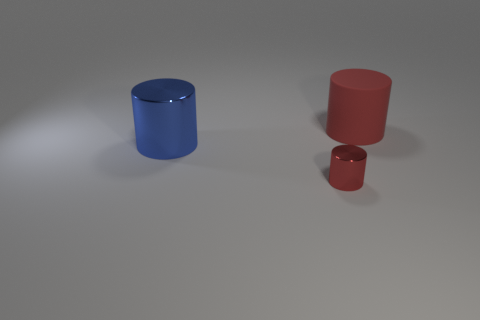How many tiny objects are red rubber objects or cyan metallic balls?
Provide a short and direct response. 0. There is a tiny red thing that is the same shape as the large blue metal thing; what material is it?
Offer a terse response. Metal. Is there any other thing that has the same material as the large red cylinder?
Your answer should be compact. No. What is the color of the small metal thing?
Provide a succinct answer. Red. Does the rubber cylinder have the same color as the small shiny object?
Make the answer very short. Yes. There is a big cylinder right of the blue cylinder; how many big red objects are on the left side of it?
Your answer should be compact. 0. There is a cylinder that is to the right of the blue object and in front of the matte cylinder; what is its size?
Provide a short and direct response. Small. What material is the large cylinder to the right of the tiny metal thing?
Your response must be concise. Rubber. Is there a large brown shiny object that has the same shape as the large blue object?
Keep it short and to the point. No. What number of small things have the same shape as the big red object?
Provide a short and direct response. 1. 